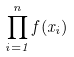<formula> <loc_0><loc_0><loc_500><loc_500>\prod _ { i = 1 } ^ { n } f ( x _ { i } )</formula> 